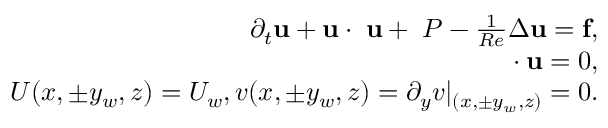Convert formula to latex. <formula><loc_0><loc_0><loc_500><loc_500>\begin{array} { r } { \partial _ { t } u + u \cdot \nabla u + \nabla P - \frac { 1 } { R e } \Delta u = f , } \\ { \nabla \cdot u = 0 , } \\ { U ( x , \pm y _ { w } , z ) = U _ { w } , v ( x , \pm y _ { w } , z ) = \partial _ { y } v | _ { ( x , \pm y _ { w } , z ) } = 0 . } \end{array}</formula> 